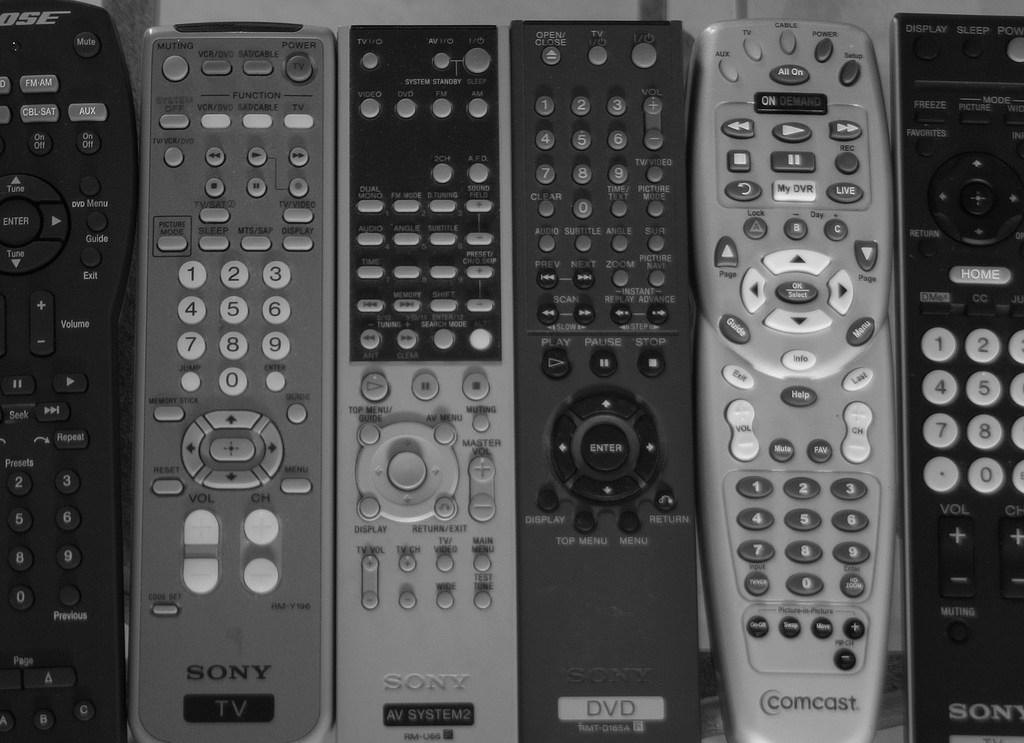What objects are present in the image? There are remotes in the image. What colors are the remotes? The remotes are in black, ash, and grey colors. What is the color of the surface where the remotes are placed? The remotes are on a white and ash color surface. What time is displayed on the remotes in the image? There is no time displayed on the remotes or in the image, as they are simply remote controls. 